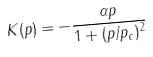Convert formula to latex. <formula><loc_0><loc_0><loc_500><loc_500>K ( p ) = - \frac { \alpha p } { 1 + ( p / p _ { c } ) ^ { 2 } }</formula> 